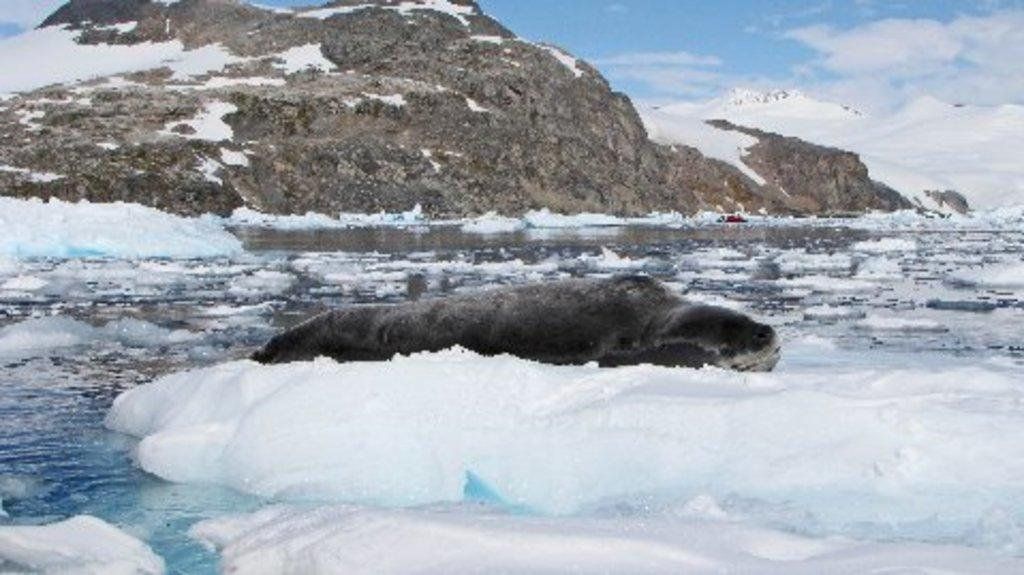What is at the bottom of the image? There is ice and water at the bottom of the image. What type of natural features can be seen in the image? Hills are visible in the image. What is present in the sky in the image? Clouds are present in the image. What else can be seen in the sky in the image? The sky is visible in the image. What type of jewel is the man holding in the image? There is no man or jewel present in the image; it features ice, water, hills, clouds, and the sky. 